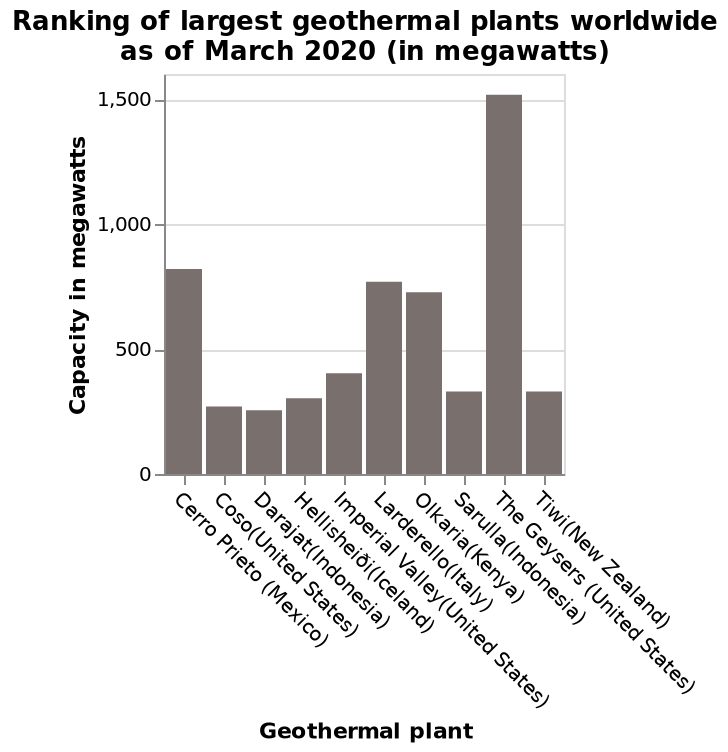<image>
Describe the following image in detail Here a bar plot is named Ranking of largest geothermal plants worldwide as of March 2020 (in megawatts). The y-axis plots Capacity in megawatts while the x-axis measures Geothermal plant. Which country has the largest number of plants among the listed countries?  The United States has the largest number of plants among the listed countries. Offer a thorough analysis of the image. The geysers, in the united states, have the highest capacity in megawatts. The United states have the largest number of plants out of the country listed. The united states also produces the highest number of megawatts across all the listed countries with plants. Darajat has the lowest output. 